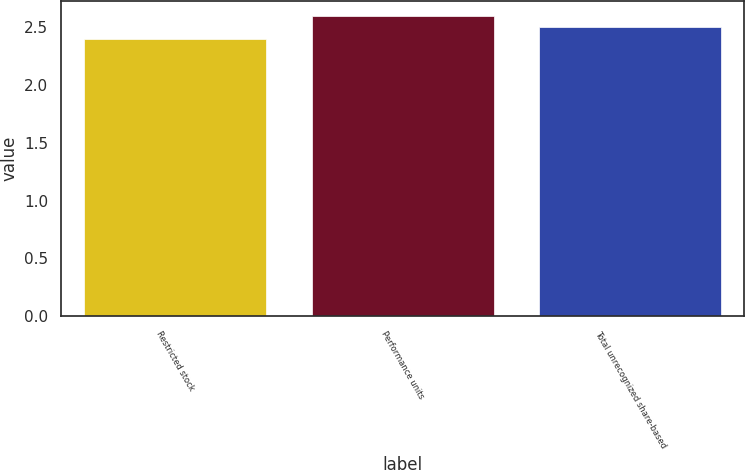Convert chart to OTSL. <chart><loc_0><loc_0><loc_500><loc_500><bar_chart><fcel>Restricted stock<fcel>Performance units<fcel>Total unrecognized share-based<nl><fcel>2.4<fcel>2.6<fcel>2.5<nl></chart> 